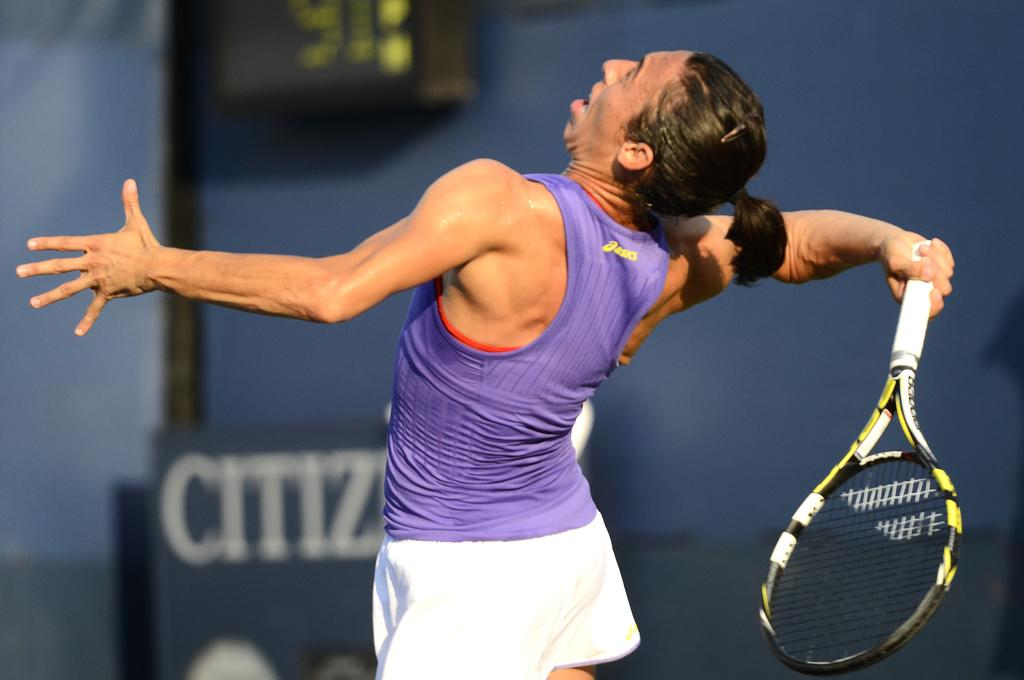What is the main subject of the image? The main subject of the image is a sports person. What is the sports person holding in the image? The sports person is holding a bat in the image. What color is the top that the sports person is wearing? The sports person is wearing a violet top in the image. What color are the shorts that the sports person is wearing? The sports person is wearing white shorts in the image. What is the hairstyle of the sports person in the image? The sports person has short hair in the image. What type of monkey can be seen performing an operation in the image? There is no monkey or operation present in the image; it features a sports person holding a bat. What kind of pest is shown crawling on the sports person's shorts in the image? There is no pest present in the image; the sports person is wearing white shorts. 